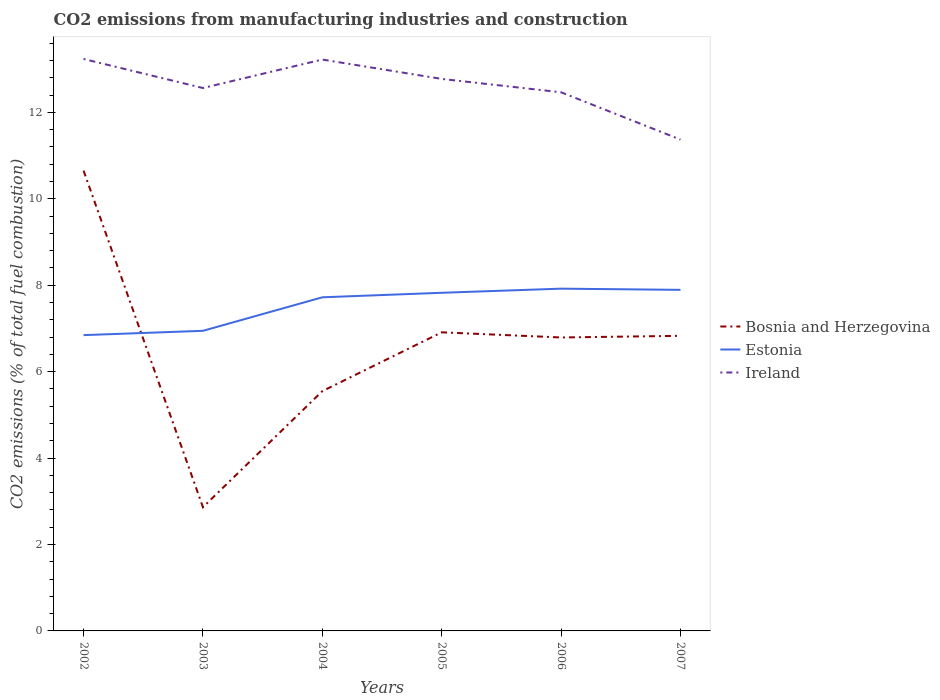How many different coloured lines are there?
Your response must be concise. 3. Across all years, what is the maximum amount of CO2 emitted in Ireland?
Ensure brevity in your answer.  11.37. In which year was the amount of CO2 emitted in Ireland maximum?
Keep it short and to the point. 2007. What is the total amount of CO2 emitted in Estonia in the graph?
Offer a very short reply. -0.88. What is the difference between the highest and the second highest amount of CO2 emitted in Ireland?
Offer a very short reply. 1.86. Is the amount of CO2 emitted in Ireland strictly greater than the amount of CO2 emitted in Bosnia and Herzegovina over the years?
Ensure brevity in your answer.  No. How many years are there in the graph?
Your response must be concise. 6. Are the values on the major ticks of Y-axis written in scientific E-notation?
Ensure brevity in your answer.  No. Does the graph contain any zero values?
Offer a terse response. No. Does the graph contain grids?
Give a very brief answer. No. Where does the legend appear in the graph?
Ensure brevity in your answer.  Center right. How many legend labels are there?
Your response must be concise. 3. What is the title of the graph?
Provide a short and direct response. CO2 emissions from manufacturing industries and construction. What is the label or title of the X-axis?
Offer a terse response. Years. What is the label or title of the Y-axis?
Offer a terse response. CO2 emissions (% of total fuel combustion). What is the CO2 emissions (% of total fuel combustion) of Bosnia and Herzegovina in 2002?
Give a very brief answer. 10.65. What is the CO2 emissions (% of total fuel combustion) of Estonia in 2002?
Give a very brief answer. 6.84. What is the CO2 emissions (% of total fuel combustion) in Ireland in 2002?
Provide a succinct answer. 13.23. What is the CO2 emissions (% of total fuel combustion) in Bosnia and Herzegovina in 2003?
Your answer should be very brief. 2.86. What is the CO2 emissions (% of total fuel combustion) of Estonia in 2003?
Your answer should be compact. 6.94. What is the CO2 emissions (% of total fuel combustion) of Ireland in 2003?
Offer a very short reply. 12.56. What is the CO2 emissions (% of total fuel combustion) of Bosnia and Herzegovina in 2004?
Provide a succinct answer. 5.55. What is the CO2 emissions (% of total fuel combustion) in Estonia in 2004?
Offer a very short reply. 7.72. What is the CO2 emissions (% of total fuel combustion) of Ireland in 2004?
Your response must be concise. 13.22. What is the CO2 emissions (% of total fuel combustion) in Bosnia and Herzegovina in 2005?
Make the answer very short. 6.91. What is the CO2 emissions (% of total fuel combustion) in Estonia in 2005?
Give a very brief answer. 7.82. What is the CO2 emissions (% of total fuel combustion) of Ireland in 2005?
Offer a terse response. 12.77. What is the CO2 emissions (% of total fuel combustion) in Bosnia and Herzegovina in 2006?
Give a very brief answer. 6.79. What is the CO2 emissions (% of total fuel combustion) in Estonia in 2006?
Provide a succinct answer. 7.92. What is the CO2 emissions (% of total fuel combustion) in Ireland in 2006?
Provide a succinct answer. 12.46. What is the CO2 emissions (% of total fuel combustion) of Bosnia and Herzegovina in 2007?
Keep it short and to the point. 6.83. What is the CO2 emissions (% of total fuel combustion) of Estonia in 2007?
Offer a very short reply. 7.89. What is the CO2 emissions (% of total fuel combustion) of Ireland in 2007?
Offer a very short reply. 11.37. Across all years, what is the maximum CO2 emissions (% of total fuel combustion) in Bosnia and Herzegovina?
Give a very brief answer. 10.65. Across all years, what is the maximum CO2 emissions (% of total fuel combustion) in Estonia?
Offer a very short reply. 7.92. Across all years, what is the maximum CO2 emissions (% of total fuel combustion) of Ireland?
Provide a short and direct response. 13.23. Across all years, what is the minimum CO2 emissions (% of total fuel combustion) in Bosnia and Herzegovina?
Your answer should be very brief. 2.86. Across all years, what is the minimum CO2 emissions (% of total fuel combustion) in Estonia?
Offer a terse response. 6.84. Across all years, what is the minimum CO2 emissions (% of total fuel combustion) in Ireland?
Offer a terse response. 11.37. What is the total CO2 emissions (% of total fuel combustion) of Bosnia and Herzegovina in the graph?
Give a very brief answer. 39.59. What is the total CO2 emissions (% of total fuel combustion) of Estonia in the graph?
Your answer should be very brief. 45.15. What is the total CO2 emissions (% of total fuel combustion) of Ireland in the graph?
Give a very brief answer. 75.63. What is the difference between the CO2 emissions (% of total fuel combustion) of Bosnia and Herzegovina in 2002 and that in 2003?
Offer a very short reply. 7.79. What is the difference between the CO2 emissions (% of total fuel combustion) in Estonia in 2002 and that in 2003?
Offer a terse response. -0.1. What is the difference between the CO2 emissions (% of total fuel combustion) in Ireland in 2002 and that in 2003?
Your answer should be very brief. 0.67. What is the difference between the CO2 emissions (% of total fuel combustion) of Bosnia and Herzegovina in 2002 and that in 2004?
Keep it short and to the point. 5.1. What is the difference between the CO2 emissions (% of total fuel combustion) in Estonia in 2002 and that in 2004?
Your answer should be very brief. -0.88. What is the difference between the CO2 emissions (% of total fuel combustion) of Ireland in 2002 and that in 2004?
Make the answer very short. 0.01. What is the difference between the CO2 emissions (% of total fuel combustion) in Bosnia and Herzegovina in 2002 and that in 2005?
Provide a short and direct response. 3.74. What is the difference between the CO2 emissions (% of total fuel combustion) in Estonia in 2002 and that in 2005?
Your answer should be very brief. -0.98. What is the difference between the CO2 emissions (% of total fuel combustion) of Ireland in 2002 and that in 2005?
Make the answer very short. 0.46. What is the difference between the CO2 emissions (% of total fuel combustion) of Bosnia and Herzegovina in 2002 and that in 2006?
Keep it short and to the point. 3.86. What is the difference between the CO2 emissions (% of total fuel combustion) of Estonia in 2002 and that in 2006?
Offer a terse response. -1.08. What is the difference between the CO2 emissions (% of total fuel combustion) in Ireland in 2002 and that in 2006?
Your response must be concise. 0.77. What is the difference between the CO2 emissions (% of total fuel combustion) of Bosnia and Herzegovina in 2002 and that in 2007?
Make the answer very short. 3.82. What is the difference between the CO2 emissions (% of total fuel combustion) of Estonia in 2002 and that in 2007?
Give a very brief answer. -1.05. What is the difference between the CO2 emissions (% of total fuel combustion) of Ireland in 2002 and that in 2007?
Give a very brief answer. 1.86. What is the difference between the CO2 emissions (% of total fuel combustion) of Bosnia and Herzegovina in 2003 and that in 2004?
Ensure brevity in your answer.  -2.69. What is the difference between the CO2 emissions (% of total fuel combustion) in Estonia in 2003 and that in 2004?
Offer a terse response. -0.78. What is the difference between the CO2 emissions (% of total fuel combustion) of Ireland in 2003 and that in 2004?
Your response must be concise. -0.66. What is the difference between the CO2 emissions (% of total fuel combustion) in Bosnia and Herzegovina in 2003 and that in 2005?
Your answer should be very brief. -4.05. What is the difference between the CO2 emissions (% of total fuel combustion) in Estonia in 2003 and that in 2005?
Give a very brief answer. -0.88. What is the difference between the CO2 emissions (% of total fuel combustion) in Ireland in 2003 and that in 2005?
Your response must be concise. -0.21. What is the difference between the CO2 emissions (% of total fuel combustion) in Bosnia and Herzegovina in 2003 and that in 2006?
Ensure brevity in your answer.  -3.93. What is the difference between the CO2 emissions (% of total fuel combustion) of Estonia in 2003 and that in 2006?
Give a very brief answer. -0.98. What is the difference between the CO2 emissions (% of total fuel combustion) of Ireland in 2003 and that in 2006?
Provide a succinct answer. 0.1. What is the difference between the CO2 emissions (% of total fuel combustion) in Bosnia and Herzegovina in 2003 and that in 2007?
Your answer should be very brief. -3.97. What is the difference between the CO2 emissions (% of total fuel combustion) of Estonia in 2003 and that in 2007?
Your answer should be compact. -0.95. What is the difference between the CO2 emissions (% of total fuel combustion) in Ireland in 2003 and that in 2007?
Your response must be concise. 1.19. What is the difference between the CO2 emissions (% of total fuel combustion) of Bosnia and Herzegovina in 2004 and that in 2005?
Your answer should be very brief. -1.36. What is the difference between the CO2 emissions (% of total fuel combustion) in Estonia in 2004 and that in 2005?
Make the answer very short. -0.1. What is the difference between the CO2 emissions (% of total fuel combustion) in Ireland in 2004 and that in 2005?
Your response must be concise. 0.45. What is the difference between the CO2 emissions (% of total fuel combustion) of Bosnia and Herzegovina in 2004 and that in 2006?
Your answer should be compact. -1.24. What is the difference between the CO2 emissions (% of total fuel combustion) of Estonia in 2004 and that in 2006?
Your response must be concise. -0.2. What is the difference between the CO2 emissions (% of total fuel combustion) of Ireland in 2004 and that in 2006?
Offer a terse response. 0.76. What is the difference between the CO2 emissions (% of total fuel combustion) in Bosnia and Herzegovina in 2004 and that in 2007?
Offer a terse response. -1.28. What is the difference between the CO2 emissions (% of total fuel combustion) in Estonia in 2004 and that in 2007?
Ensure brevity in your answer.  -0.17. What is the difference between the CO2 emissions (% of total fuel combustion) in Ireland in 2004 and that in 2007?
Your answer should be very brief. 1.85. What is the difference between the CO2 emissions (% of total fuel combustion) of Bosnia and Herzegovina in 2005 and that in 2006?
Give a very brief answer. 0.12. What is the difference between the CO2 emissions (% of total fuel combustion) of Estonia in 2005 and that in 2006?
Provide a succinct answer. -0.1. What is the difference between the CO2 emissions (% of total fuel combustion) of Ireland in 2005 and that in 2006?
Your response must be concise. 0.31. What is the difference between the CO2 emissions (% of total fuel combustion) of Bosnia and Herzegovina in 2005 and that in 2007?
Keep it short and to the point. 0.08. What is the difference between the CO2 emissions (% of total fuel combustion) in Estonia in 2005 and that in 2007?
Give a very brief answer. -0.07. What is the difference between the CO2 emissions (% of total fuel combustion) of Ireland in 2005 and that in 2007?
Ensure brevity in your answer.  1.4. What is the difference between the CO2 emissions (% of total fuel combustion) in Bosnia and Herzegovina in 2006 and that in 2007?
Give a very brief answer. -0.04. What is the difference between the CO2 emissions (% of total fuel combustion) in Estonia in 2006 and that in 2007?
Make the answer very short. 0.03. What is the difference between the CO2 emissions (% of total fuel combustion) of Ireland in 2006 and that in 2007?
Give a very brief answer. 1.09. What is the difference between the CO2 emissions (% of total fuel combustion) in Bosnia and Herzegovina in 2002 and the CO2 emissions (% of total fuel combustion) in Estonia in 2003?
Your response must be concise. 3.71. What is the difference between the CO2 emissions (% of total fuel combustion) of Bosnia and Herzegovina in 2002 and the CO2 emissions (% of total fuel combustion) of Ireland in 2003?
Ensure brevity in your answer.  -1.91. What is the difference between the CO2 emissions (% of total fuel combustion) in Estonia in 2002 and the CO2 emissions (% of total fuel combustion) in Ireland in 2003?
Your response must be concise. -5.72. What is the difference between the CO2 emissions (% of total fuel combustion) in Bosnia and Herzegovina in 2002 and the CO2 emissions (% of total fuel combustion) in Estonia in 2004?
Ensure brevity in your answer.  2.93. What is the difference between the CO2 emissions (% of total fuel combustion) in Bosnia and Herzegovina in 2002 and the CO2 emissions (% of total fuel combustion) in Ireland in 2004?
Make the answer very short. -2.57. What is the difference between the CO2 emissions (% of total fuel combustion) in Estonia in 2002 and the CO2 emissions (% of total fuel combustion) in Ireland in 2004?
Provide a short and direct response. -6.38. What is the difference between the CO2 emissions (% of total fuel combustion) in Bosnia and Herzegovina in 2002 and the CO2 emissions (% of total fuel combustion) in Estonia in 2005?
Make the answer very short. 2.83. What is the difference between the CO2 emissions (% of total fuel combustion) of Bosnia and Herzegovina in 2002 and the CO2 emissions (% of total fuel combustion) of Ireland in 2005?
Your response must be concise. -2.12. What is the difference between the CO2 emissions (% of total fuel combustion) in Estonia in 2002 and the CO2 emissions (% of total fuel combustion) in Ireland in 2005?
Ensure brevity in your answer.  -5.93. What is the difference between the CO2 emissions (% of total fuel combustion) in Bosnia and Herzegovina in 2002 and the CO2 emissions (% of total fuel combustion) in Estonia in 2006?
Offer a very short reply. 2.73. What is the difference between the CO2 emissions (% of total fuel combustion) in Bosnia and Herzegovina in 2002 and the CO2 emissions (% of total fuel combustion) in Ireland in 2006?
Give a very brief answer. -1.81. What is the difference between the CO2 emissions (% of total fuel combustion) of Estonia in 2002 and the CO2 emissions (% of total fuel combustion) of Ireland in 2006?
Your response must be concise. -5.62. What is the difference between the CO2 emissions (% of total fuel combustion) in Bosnia and Herzegovina in 2002 and the CO2 emissions (% of total fuel combustion) in Estonia in 2007?
Keep it short and to the point. 2.76. What is the difference between the CO2 emissions (% of total fuel combustion) of Bosnia and Herzegovina in 2002 and the CO2 emissions (% of total fuel combustion) of Ireland in 2007?
Give a very brief answer. -0.72. What is the difference between the CO2 emissions (% of total fuel combustion) in Estonia in 2002 and the CO2 emissions (% of total fuel combustion) in Ireland in 2007?
Your answer should be very brief. -4.53. What is the difference between the CO2 emissions (% of total fuel combustion) in Bosnia and Herzegovina in 2003 and the CO2 emissions (% of total fuel combustion) in Estonia in 2004?
Keep it short and to the point. -4.86. What is the difference between the CO2 emissions (% of total fuel combustion) of Bosnia and Herzegovina in 2003 and the CO2 emissions (% of total fuel combustion) of Ireland in 2004?
Provide a succinct answer. -10.36. What is the difference between the CO2 emissions (% of total fuel combustion) in Estonia in 2003 and the CO2 emissions (% of total fuel combustion) in Ireland in 2004?
Your response must be concise. -6.28. What is the difference between the CO2 emissions (% of total fuel combustion) of Bosnia and Herzegovina in 2003 and the CO2 emissions (% of total fuel combustion) of Estonia in 2005?
Provide a succinct answer. -4.96. What is the difference between the CO2 emissions (% of total fuel combustion) in Bosnia and Herzegovina in 2003 and the CO2 emissions (% of total fuel combustion) in Ireland in 2005?
Your response must be concise. -9.91. What is the difference between the CO2 emissions (% of total fuel combustion) of Estonia in 2003 and the CO2 emissions (% of total fuel combustion) of Ireland in 2005?
Your answer should be very brief. -5.83. What is the difference between the CO2 emissions (% of total fuel combustion) in Bosnia and Herzegovina in 2003 and the CO2 emissions (% of total fuel combustion) in Estonia in 2006?
Offer a terse response. -5.06. What is the difference between the CO2 emissions (% of total fuel combustion) in Bosnia and Herzegovina in 2003 and the CO2 emissions (% of total fuel combustion) in Ireland in 2006?
Ensure brevity in your answer.  -9.6. What is the difference between the CO2 emissions (% of total fuel combustion) of Estonia in 2003 and the CO2 emissions (% of total fuel combustion) of Ireland in 2006?
Your answer should be very brief. -5.52. What is the difference between the CO2 emissions (% of total fuel combustion) in Bosnia and Herzegovina in 2003 and the CO2 emissions (% of total fuel combustion) in Estonia in 2007?
Offer a very short reply. -5.03. What is the difference between the CO2 emissions (% of total fuel combustion) of Bosnia and Herzegovina in 2003 and the CO2 emissions (% of total fuel combustion) of Ireland in 2007?
Keep it short and to the point. -8.51. What is the difference between the CO2 emissions (% of total fuel combustion) of Estonia in 2003 and the CO2 emissions (% of total fuel combustion) of Ireland in 2007?
Provide a short and direct response. -4.43. What is the difference between the CO2 emissions (% of total fuel combustion) of Bosnia and Herzegovina in 2004 and the CO2 emissions (% of total fuel combustion) of Estonia in 2005?
Your answer should be very brief. -2.28. What is the difference between the CO2 emissions (% of total fuel combustion) of Bosnia and Herzegovina in 2004 and the CO2 emissions (% of total fuel combustion) of Ireland in 2005?
Provide a succinct answer. -7.23. What is the difference between the CO2 emissions (% of total fuel combustion) of Estonia in 2004 and the CO2 emissions (% of total fuel combustion) of Ireland in 2005?
Give a very brief answer. -5.05. What is the difference between the CO2 emissions (% of total fuel combustion) in Bosnia and Herzegovina in 2004 and the CO2 emissions (% of total fuel combustion) in Estonia in 2006?
Give a very brief answer. -2.37. What is the difference between the CO2 emissions (% of total fuel combustion) of Bosnia and Herzegovina in 2004 and the CO2 emissions (% of total fuel combustion) of Ireland in 2006?
Your response must be concise. -6.92. What is the difference between the CO2 emissions (% of total fuel combustion) in Estonia in 2004 and the CO2 emissions (% of total fuel combustion) in Ireland in 2006?
Offer a very short reply. -4.74. What is the difference between the CO2 emissions (% of total fuel combustion) of Bosnia and Herzegovina in 2004 and the CO2 emissions (% of total fuel combustion) of Estonia in 2007?
Keep it short and to the point. -2.34. What is the difference between the CO2 emissions (% of total fuel combustion) of Bosnia and Herzegovina in 2004 and the CO2 emissions (% of total fuel combustion) of Ireland in 2007?
Offer a very short reply. -5.82. What is the difference between the CO2 emissions (% of total fuel combustion) of Estonia in 2004 and the CO2 emissions (% of total fuel combustion) of Ireland in 2007?
Ensure brevity in your answer.  -3.65. What is the difference between the CO2 emissions (% of total fuel combustion) of Bosnia and Herzegovina in 2005 and the CO2 emissions (% of total fuel combustion) of Estonia in 2006?
Your response must be concise. -1.01. What is the difference between the CO2 emissions (% of total fuel combustion) of Bosnia and Herzegovina in 2005 and the CO2 emissions (% of total fuel combustion) of Ireland in 2006?
Keep it short and to the point. -5.55. What is the difference between the CO2 emissions (% of total fuel combustion) in Estonia in 2005 and the CO2 emissions (% of total fuel combustion) in Ireland in 2006?
Your answer should be compact. -4.64. What is the difference between the CO2 emissions (% of total fuel combustion) in Bosnia and Herzegovina in 2005 and the CO2 emissions (% of total fuel combustion) in Estonia in 2007?
Give a very brief answer. -0.98. What is the difference between the CO2 emissions (% of total fuel combustion) of Bosnia and Herzegovina in 2005 and the CO2 emissions (% of total fuel combustion) of Ireland in 2007?
Your answer should be compact. -4.46. What is the difference between the CO2 emissions (% of total fuel combustion) in Estonia in 2005 and the CO2 emissions (% of total fuel combustion) in Ireland in 2007?
Provide a succinct answer. -3.55. What is the difference between the CO2 emissions (% of total fuel combustion) of Bosnia and Herzegovina in 2006 and the CO2 emissions (% of total fuel combustion) of Estonia in 2007?
Keep it short and to the point. -1.1. What is the difference between the CO2 emissions (% of total fuel combustion) of Bosnia and Herzegovina in 2006 and the CO2 emissions (% of total fuel combustion) of Ireland in 2007?
Offer a terse response. -4.58. What is the difference between the CO2 emissions (% of total fuel combustion) in Estonia in 2006 and the CO2 emissions (% of total fuel combustion) in Ireland in 2007?
Offer a terse response. -3.45. What is the average CO2 emissions (% of total fuel combustion) of Bosnia and Herzegovina per year?
Ensure brevity in your answer.  6.6. What is the average CO2 emissions (% of total fuel combustion) in Estonia per year?
Your response must be concise. 7.52. What is the average CO2 emissions (% of total fuel combustion) of Ireland per year?
Provide a succinct answer. 12.6. In the year 2002, what is the difference between the CO2 emissions (% of total fuel combustion) in Bosnia and Herzegovina and CO2 emissions (% of total fuel combustion) in Estonia?
Provide a short and direct response. 3.81. In the year 2002, what is the difference between the CO2 emissions (% of total fuel combustion) in Bosnia and Herzegovina and CO2 emissions (% of total fuel combustion) in Ireland?
Offer a very short reply. -2.58. In the year 2002, what is the difference between the CO2 emissions (% of total fuel combustion) in Estonia and CO2 emissions (% of total fuel combustion) in Ireland?
Your response must be concise. -6.39. In the year 2003, what is the difference between the CO2 emissions (% of total fuel combustion) of Bosnia and Herzegovina and CO2 emissions (% of total fuel combustion) of Estonia?
Provide a short and direct response. -4.08. In the year 2003, what is the difference between the CO2 emissions (% of total fuel combustion) in Bosnia and Herzegovina and CO2 emissions (% of total fuel combustion) in Ireland?
Ensure brevity in your answer.  -9.7. In the year 2003, what is the difference between the CO2 emissions (% of total fuel combustion) of Estonia and CO2 emissions (% of total fuel combustion) of Ireland?
Ensure brevity in your answer.  -5.62. In the year 2004, what is the difference between the CO2 emissions (% of total fuel combustion) of Bosnia and Herzegovina and CO2 emissions (% of total fuel combustion) of Estonia?
Provide a short and direct response. -2.17. In the year 2004, what is the difference between the CO2 emissions (% of total fuel combustion) in Bosnia and Herzegovina and CO2 emissions (% of total fuel combustion) in Ireland?
Ensure brevity in your answer.  -7.67. In the year 2004, what is the difference between the CO2 emissions (% of total fuel combustion) of Estonia and CO2 emissions (% of total fuel combustion) of Ireland?
Keep it short and to the point. -5.5. In the year 2005, what is the difference between the CO2 emissions (% of total fuel combustion) in Bosnia and Herzegovina and CO2 emissions (% of total fuel combustion) in Estonia?
Offer a terse response. -0.91. In the year 2005, what is the difference between the CO2 emissions (% of total fuel combustion) of Bosnia and Herzegovina and CO2 emissions (% of total fuel combustion) of Ireland?
Provide a short and direct response. -5.86. In the year 2005, what is the difference between the CO2 emissions (% of total fuel combustion) of Estonia and CO2 emissions (% of total fuel combustion) of Ireland?
Ensure brevity in your answer.  -4.95. In the year 2006, what is the difference between the CO2 emissions (% of total fuel combustion) of Bosnia and Herzegovina and CO2 emissions (% of total fuel combustion) of Estonia?
Provide a succinct answer. -1.13. In the year 2006, what is the difference between the CO2 emissions (% of total fuel combustion) in Bosnia and Herzegovina and CO2 emissions (% of total fuel combustion) in Ireland?
Make the answer very short. -5.67. In the year 2006, what is the difference between the CO2 emissions (% of total fuel combustion) of Estonia and CO2 emissions (% of total fuel combustion) of Ireland?
Offer a very short reply. -4.54. In the year 2007, what is the difference between the CO2 emissions (% of total fuel combustion) in Bosnia and Herzegovina and CO2 emissions (% of total fuel combustion) in Estonia?
Your response must be concise. -1.06. In the year 2007, what is the difference between the CO2 emissions (% of total fuel combustion) in Bosnia and Herzegovina and CO2 emissions (% of total fuel combustion) in Ireland?
Offer a very short reply. -4.54. In the year 2007, what is the difference between the CO2 emissions (% of total fuel combustion) of Estonia and CO2 emissions (% of total fuel combustion) of Ireland?
Make the answer very short. -3.48. What is the ratio of the CO2 emissions (% of total fuel combustion) of Bosnia and Herzegovina in 2002 to that in 2003?
Provide a succinct answer. 3.72. What is the ratio of the CO2 emissions (% of total fuel combustion) in Estonia in 2002 to that in 2003?
Ensure brevity in your answer.  0.99. What is the ratio of the CO2 emissions (% of total fuel combustion) in Ireland in 2002 to that in 2003?
Give a very brief answer. 1.05. What is the ratio of the CO2 emissions (% of total fuel combustion) of Bosnia and Herzegovina in 2002 to that in 2004?
Offer a very short reply. 1.92. What is the ratio of the CO2 emissions (% of total fuel combustion) of Estonia in 2002 to that in 2004?
Your answer should be very brief. 0.89. What is the ratio of the CO2 emissions (% of total fuel combustion) of Ireland in 2002 to that in 2004?
Your answer should be compact. 1. What is the ratio of the CO2 emissions (% of total fuel combustion) in Bosnia and Herzegovina in 2002 to that in 2005?
Your answer should be very brief. 1.54. What is the ratio of the CO2 emissions (% of total fuel combustion) of Estonia in 2002 to that in 2005?
Offer a very short reply. 0.87. What is the ratio of the CO2 emissions (% of total fuel combustion) in Ireland in 2002 to that in 2005?
Ensure brevity in your answer.  1.04. What is the ratio of the CO2 emissions (% of total fuel combustion) in Bosnia and Herzegovina in 2002 to that in 2006?
Offer a very short reply. 1.57. What is the ratio of the CO2 emissions (% of total fuel combustion) of Estonia in 2002 to that in 2006?
Keep it short and to the point. 0.86. What is the ratio of the CO2 emissions (% of total fuel combustion) of Ireland in 2002 to that in 2006?
Provide a short and direct response. 1.06. What is the ratio of the CO2 emissions (% of total fuel combustion) of Bosnia and Herzegovina in 2002 to that in 2007?
Offer a terse response. 1.56. What is the ratio of the CO2 emissions (% of total fuel combustion) in Estonia in 2002 to that in 2007?
Offer a very short reply. 0.87. What is the ratio of the CO2 emissions (% of total fuel combustion) of Ireland in 2002 to that in 2007?
Make the answer very short. 1.16. What is the ratio of the CO2 emissions (% of total fuel combustion) of Bosnia and Herzegovina in 2003 to that in 2004?
Give a very brief answer. 0.52. What is the ratio of the CO2 emissions (% of total fuel combustion) of Estonia in 2003 to that in 2004?
Provide a short and direct response. 0.9. What is the ratio of the CO2 emissions (% of total fuel combustion) in Ireland in 2003 to that in 2004?
Give a very brief answer. 0.95. What is the ratio of the CO2 emissions (% of total fuel combustion) of Bosnia and Herzegovina in 2003 to that in 2005?
Give a very brief answer. 0.41. What is the ratio of the CO2 emissions (% of total fuel combustion) in Estonia in 2003 to that in 2005?
Your answer should be compact. 0.89. What is the ratio of the CO2 emissions (% of total fuel combustion) in Ireland in 2003 to that in 2005?
Your answer should be very brief. 0.98. What is the ratio of the CO2 emissions (% of total fuel combustion) in Bosnia and Herzegovina in 2003 to that in 2006?
Give a very brief answer. 0.42. What is the ratio of the CO2 emissions (% of total fuel combustion) of Estonia in 2003 to that in 2006?
Make the answer very short. 0.88. What is the ratio of the CO2 emissions (% of total fuel combustion) in Ireland in 2003 to that in 2006?
Provide a succinct answer. 1.01. What is the ratio of the CO2 emissions (% of total fuel combustion) in Bosnia and Herzegovina in 2003 to that in 2007?
Make the answer very short. 0.42. What is the ratio of the CO2 emissions (% of total fuel combustion) of Estonia in 2003 to that in 2007?
Your answer should be compact. 0.88. What is the ratio of the CO2 emissions (% of total fuel combustion) of Ireland in 2003 to that in 2007?
Provide a succinct answer. 1.1. What is the ratio of the CO2 emissions (% of total fuel combustion) in Bosnia and Herzegovina in 2004 to that in 2005?
Your answer should be very brief. 0.8. What is the ratio of the CO2 emissions (% of total fuel combustion) in Estonia in 2004 to that in 2005?
Offer a terse response. 0.99. What is the ratio of the CO2 emissions (% of total fuel combustion) in Ireland in 2004 to that in 2005?
Offer a terse response. 1.04. What is the ratio of the CO2 emissions (% of total fuel combustion) in Bosnia and Herzegovina in 2004 to that in 2006?
Offer a very short reply. 0.82. What is the ratio of the CO2 emissions (% of total fuel combustion) in Estonia in 2004 to that in 2006?
Your answer should be compact. 0.97. What is the ratio of the CO2 emissions (% of total fuel combustion) of Ireland in 2004 to that in 2006?
Keep it short and to the point. 1.06. What is the ratio of the CO2 emissions (% of total fuel combustion) in Bosnia and Herzegovina in 2004 to that in 2007?
Offer a terse response. 0.81. What is the ratio of the CO2 emissions (% of total fuel combustion) in Estonia in 2004 to that in 2007?
Ensure brevity in your answer.  0.98. What is the ratio of the CO2 emissions (% of total fuel combustion) in Ireland in 2004 to that in 2007?
Offer a very short reply. 1.16. What is the ratio of the CO2 emissions (% of total fuel combustion) in Bosnia and Herzegovina in 2005 to that in 2006?
Provide a short and direct response. 1.02. What is the ratio of the CO2 emissions (% of total fuel combustion) in Estonia in 2005 to that in 2006?
Your answer should be very brief. 0.99. What is the ratio of the CO2 emissions (% of total fuel combustion) in Ireland in 2005 to that in 2006?
Offer a very short reply. 1.02. What is the ratio of the CO2 emissions (% of total fuel combustion) of Bosnia and Herzegovina in 2005 to that in 2007?
Give a very brief answer. 1.01. What is the ratio of the CO2 emissions (% of total fuel combustion) in Estonia in 2005 to that in 2007?
Ensure brevity in your answer.  0.99. What is the ratio of the CO2 emissions (% of total fuel combustion) in Ireland in 2005 to that in 2007?
Offer a very short reply. 1.12. What is the ratio of the CO2 emissions (% of total fuel combustion) of Ireland in 2006 to that in 2007?
Offer a very short reply. 1.1. What is the difference between the highest and the second highest CO2 emissions (% of total fuel combustion) of Bosnia and Herzegovina?
Your answer should be compact. 3.74. What is the difference between the highest and the second highest CO2 emissions (% of total fuel combustion) in Estonia?
Make the answer very short. 0.03. What is the difference between the highest and the second highest CO2 emissions (% of total fuel combustion) of Ireland?
Your answer should be very brief. 0.01. What is the difference between the highest and the lowest CO2 emissions (% of total fuel combustion) of Bosnia and Herzegovina?
Give a very brief answer. 7.79. What is the difference between the highest and the lowest CO2 emissions (% of total fuel combustion) in Estonia?
Your answer should be very brief. 1.08. What is the difference between the highest and the lowest CO2 emissions (% of total fuel combustion) of Ireland?
Your answer should be very brief. 1.86. 